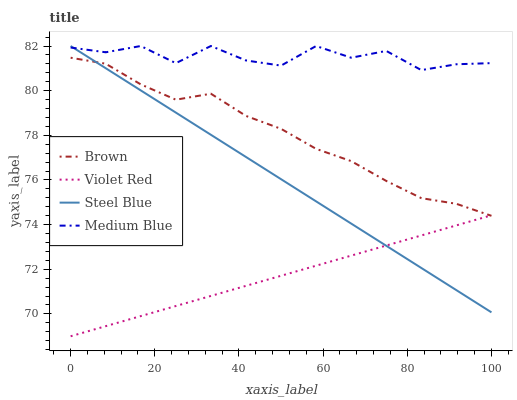Does Violet Red have the minimum area under the curve?
Answer yes or no. Yes. Does Medium Blue have the maximum area under the curve?
Answer yes or no. Yes. Does Medium Blue have the minimum area under the curve?
Answer yes or no. No. Does Violet Red have the maximum area under the curve?
Answer yes or no. No. Is Violet Red the smoothest?
Answer yes or no. Yes. Is Medium Blue the roughest?
Answer yes or no. Yes. Is Medium Blue the smoothest?
Answer yes or no. No. Is Violet Red the roughest?
Answer yes or no. No. Does Violet Red have the lowest value?
Answer yes or no. Yes. Does Medium Blue have the lowest value?
Answer yes or no. No. Does Steel Blue have the highest value?
Answer yes or no. Yes. Does Violet Red have the highest value?
Answer yes or no. No. Is Brown less than Medium Blue?
Answer yes or no. Yes. Is Medium Blue greater than Brown?
Answer yes or no. Yes. Does Violet Red intersect Steel Blue?
Answer yes or no. Yes. Is Violet Red less than Steel Blue?
Answer yes or no. No. Is Violet Red greater than Steel Blue?
Answer yes or no. No. Does Brown intersect Medium Blue?
Answer yes or no. No. 